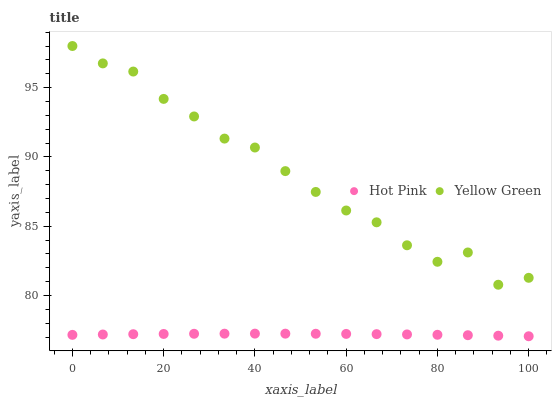Does Hot Pink have the minimum area under the curve?
Answer yes or no. Yes. Does Yellow Green have the maximum area under the curve?
Answer yes or no. Yes. Does Yellow Green have the minimum area under the curve?
Answer yes or no. No. Is Hot Pink the smoothest?
Answer yes or no. Yes. Is Yellow Green the roughest?
Answer yes or no. Yes. Is Yellow Green the smoothest?
Answer yes or no. No. Does Hot Pink have the lowest value?
Answer yes or no. Yes. Does Yellow Green have the lowest value?
Answer yes or no. No. Does Yellow Green have the highest value?
Answer yes or no. Yes. Is Hot Pink less than Yellow Green?
Answer yes or no. Yes. Is Yellow Green greater than Hot Pink?
Answer yes or no. Yes. Does Hot Pink intersect Yellow Green?
Answer yes or no. No. 